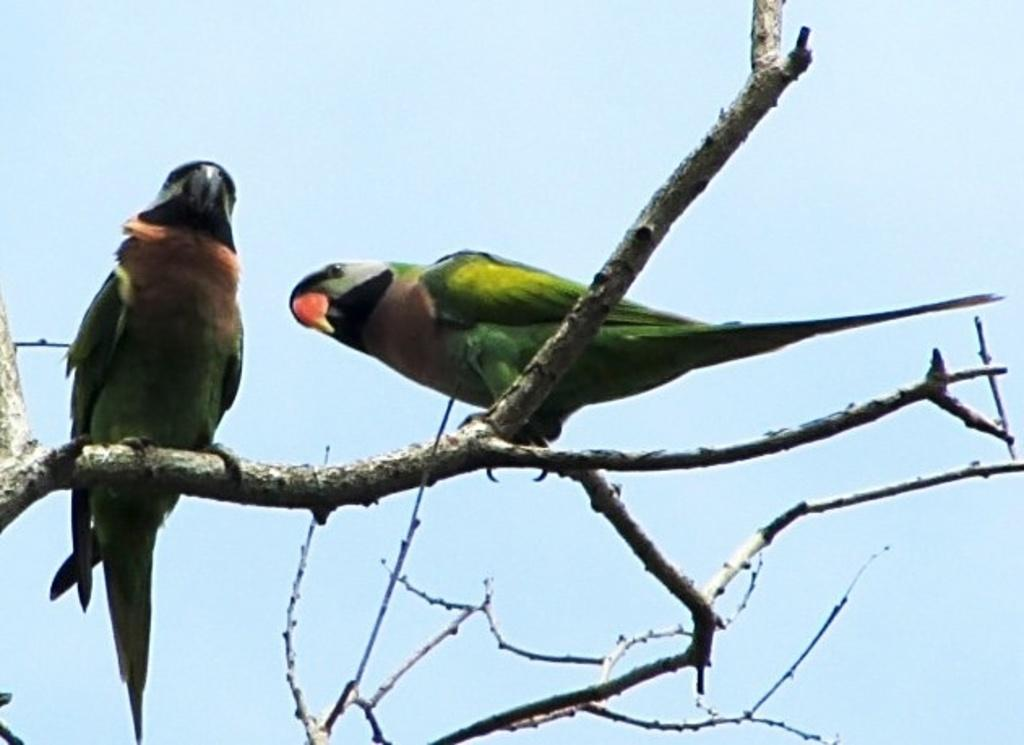What animals are present on the branch in the image? There are birds on a branch in the image. What can be seen in the background of the image? There is a sky visible in the background of the image. What type of rose can be seen growing on the branch with the birds in the image? There is no rose present in the image; it features birds on a branch with a sky visible in the background. 